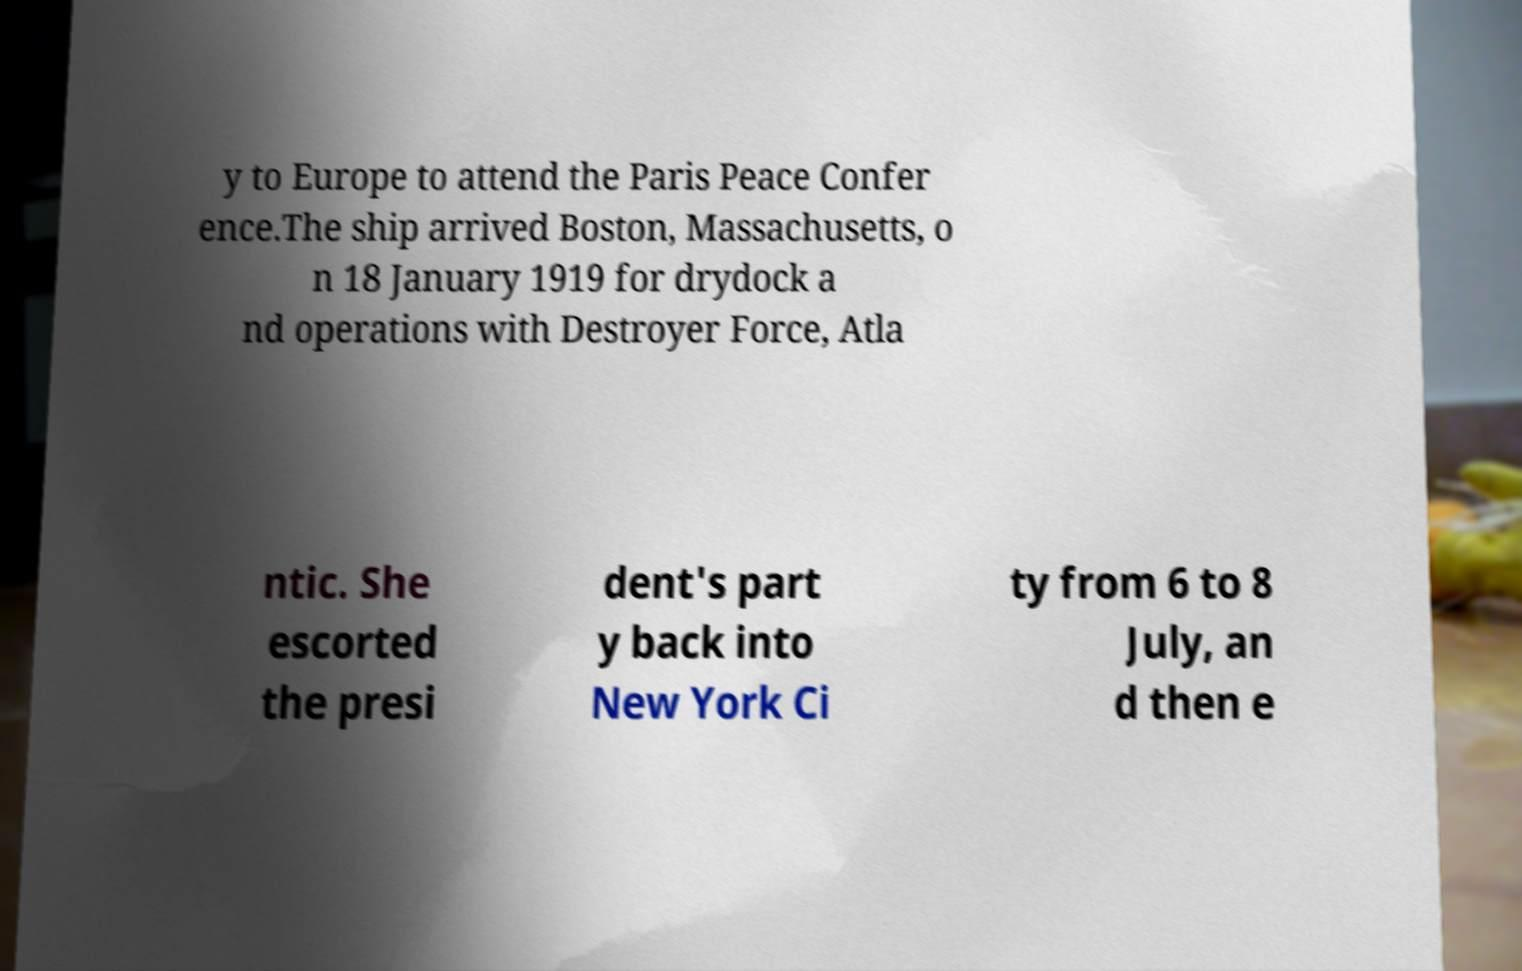Could you extract and type out the text from this image? y to Europe to attend the Paris Peace Confer ence.The ship arrived Boston, Massachusetts, o n 18 January 1919 for drydock a nd operations with Destroyer Force, Atla ntic. She escorted the presi dent's part y back into New York Ci ty from 6 to 8 July, an d then e 